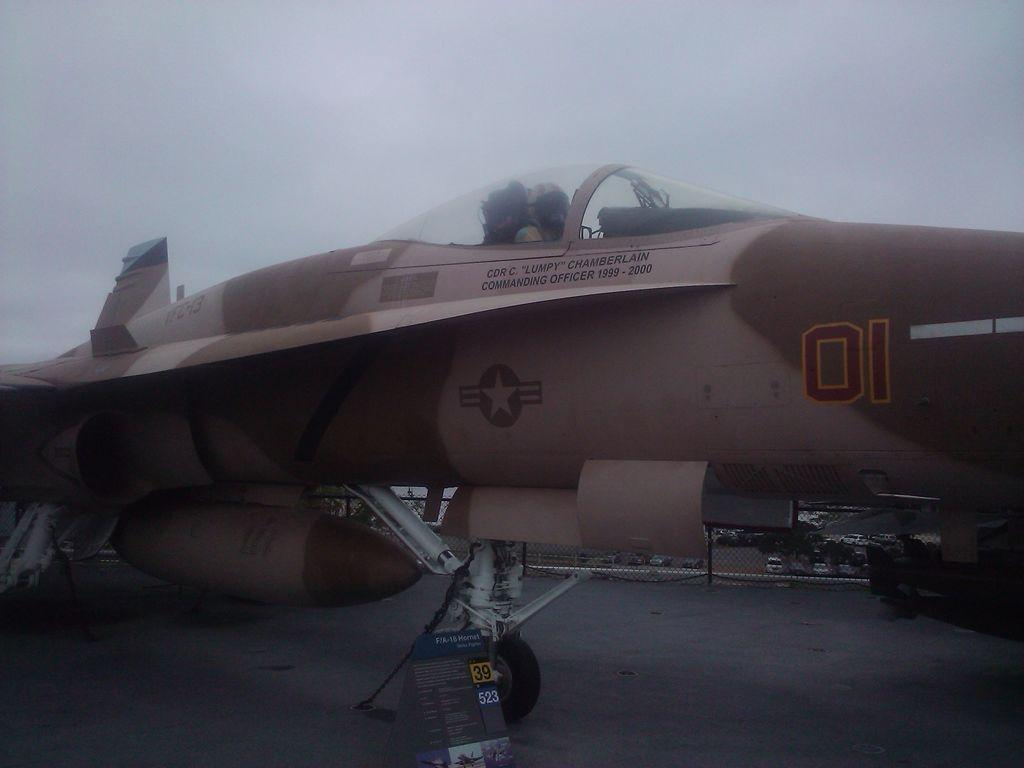What is the main subject of the image? The main subject of the image is an aircraft on the ground. Can you describe the person in the image? There is a person in the image, but no specific details about them are provided. What can be seen in the sky in the image? The sky is visible at the top of the image, but no specific details about the sky are provided. What type of bells can be heard ringing in the image? There are no bells present in the image, and therefore no sound can be heard. What type of steel is used to construct the aircraft in the image? The type of steel used to construct the aircraft is not visible or mentioned in the image. 